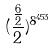Convert formula to latex. <formula><loc_0><loc_0><loc_500><loc_500>( \frac { \frac { 6 } { 2 } } { 2 } ) ^ { 8 ^ { 4 5 3 } }</formula> 